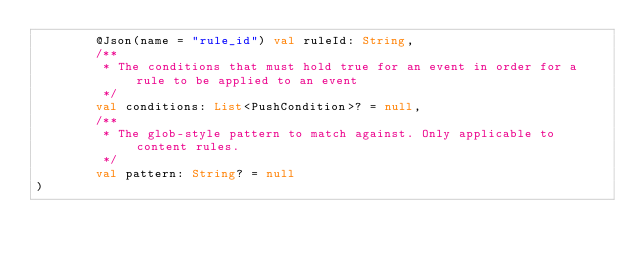Convert code to text. <code><loc_0><loc_0><loc_500><loc_500><_Kotlin_>        @Json(name = "rule_id") val ruleId: String,
        /**
         * The conditions that must hold true for an event in order for a rule to be applied to an event
         */
        val conditions: List<PushCondition>? = null,
        /**
         * The glob-style pattern to match against. Only applicable to content rules.
         */
        val pattern: String? = null
)
</code> 